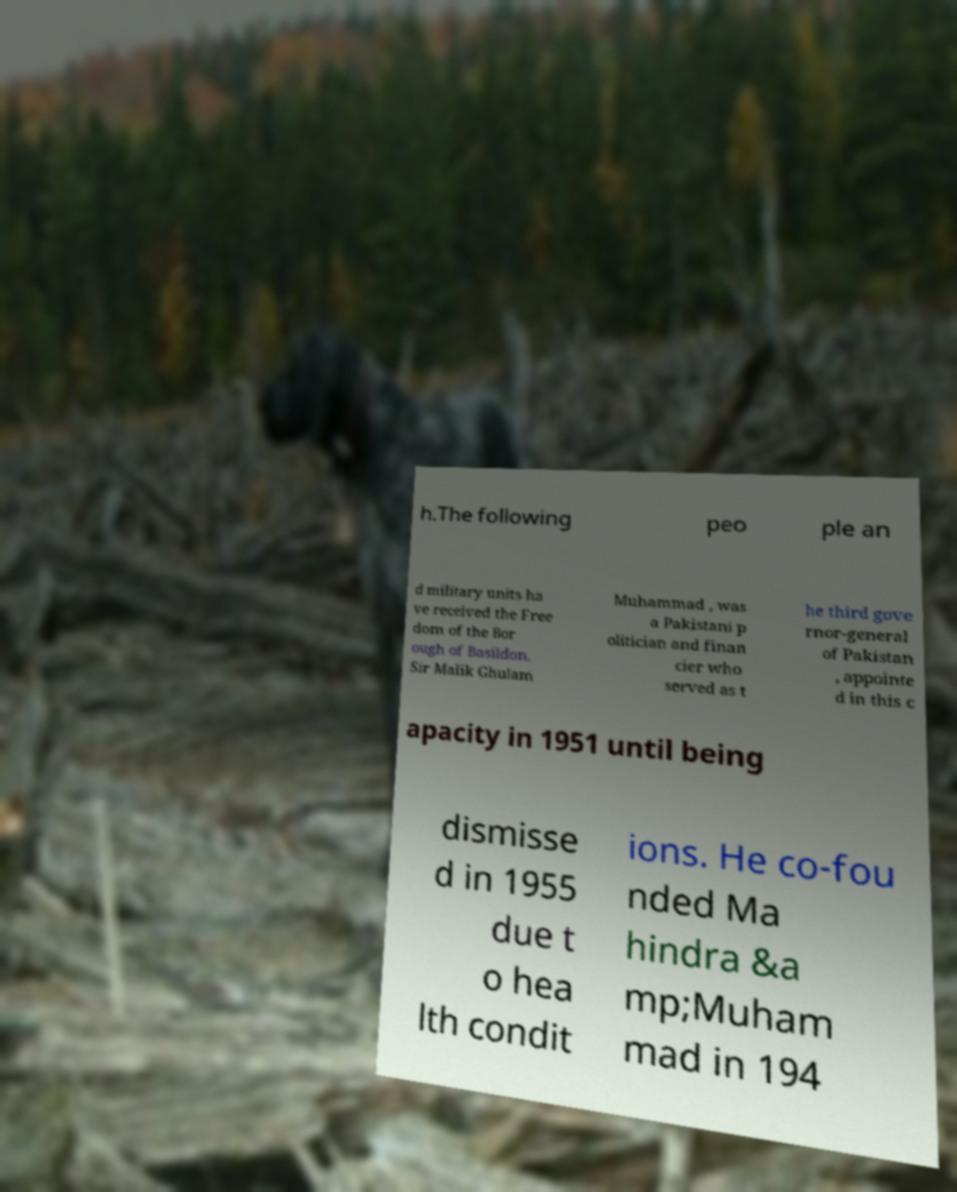There's text embedded in this image that I need extracted. Can you transcribe it verbatim? h.The following peo ple an d military units ha ve received the Free dom of the Bor ough of Basildon. Sir Malik Ghulam Muhammad , was a Pakistani p olitician and finan cier who served as t he third gove rnor-general of Pakistan , appointe d in this c apacity in 1951 until being dismisse d in 1955 due t o hea lth condit ions. He co-fou nded Ma hindra &a mp;Muham mad in 194 